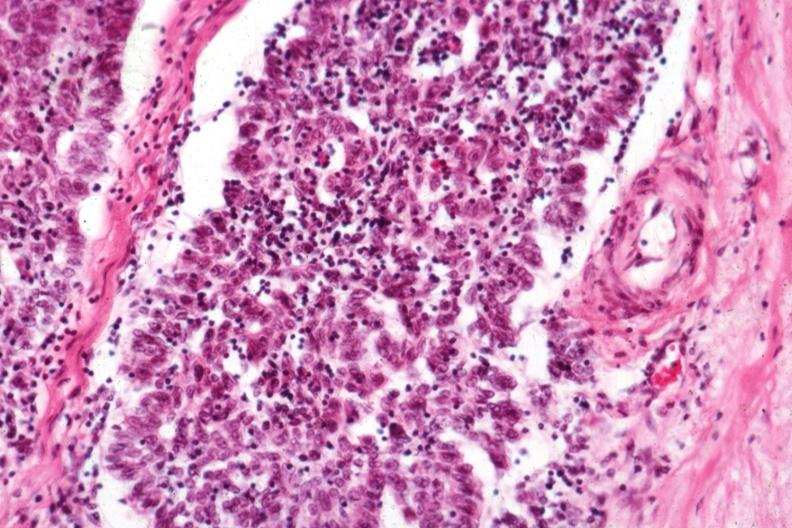s abruption present?
Answer the question using a single word or phrase. No 